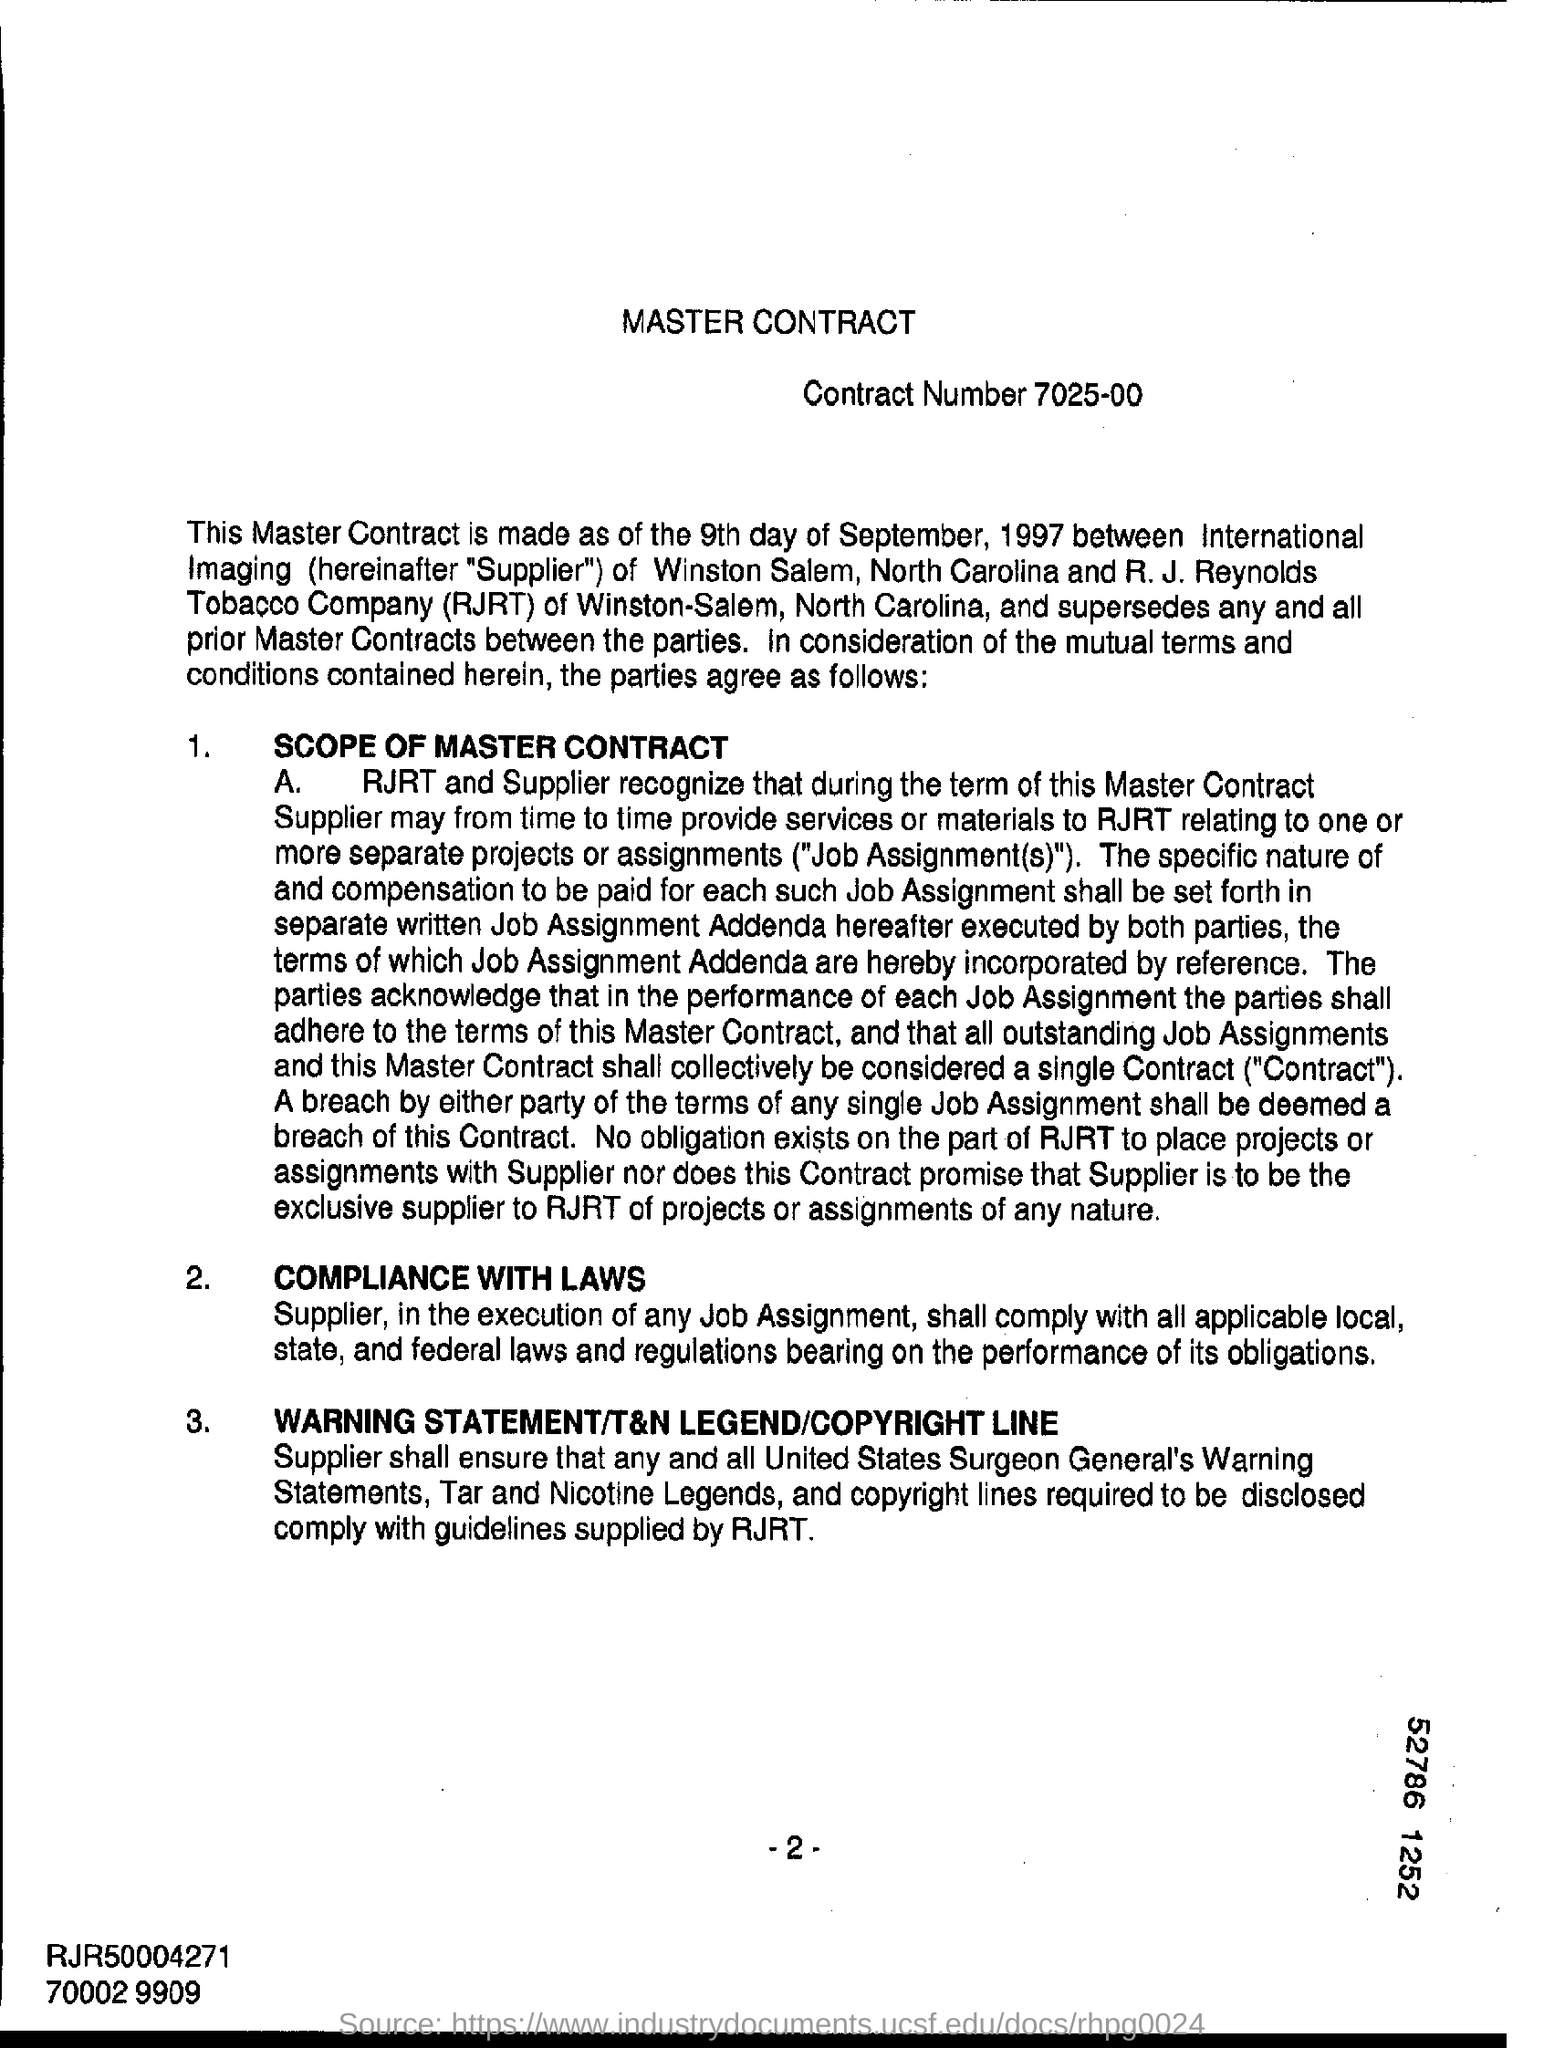What is the contract number ?
Provide a succinct answer. 7025-00. What is the acronym of r.j. reynolds tobacco company ?
Your answer should be very brief. Rjrt. What is the heading of the page ?
Give a very brief answer. Master contract. 